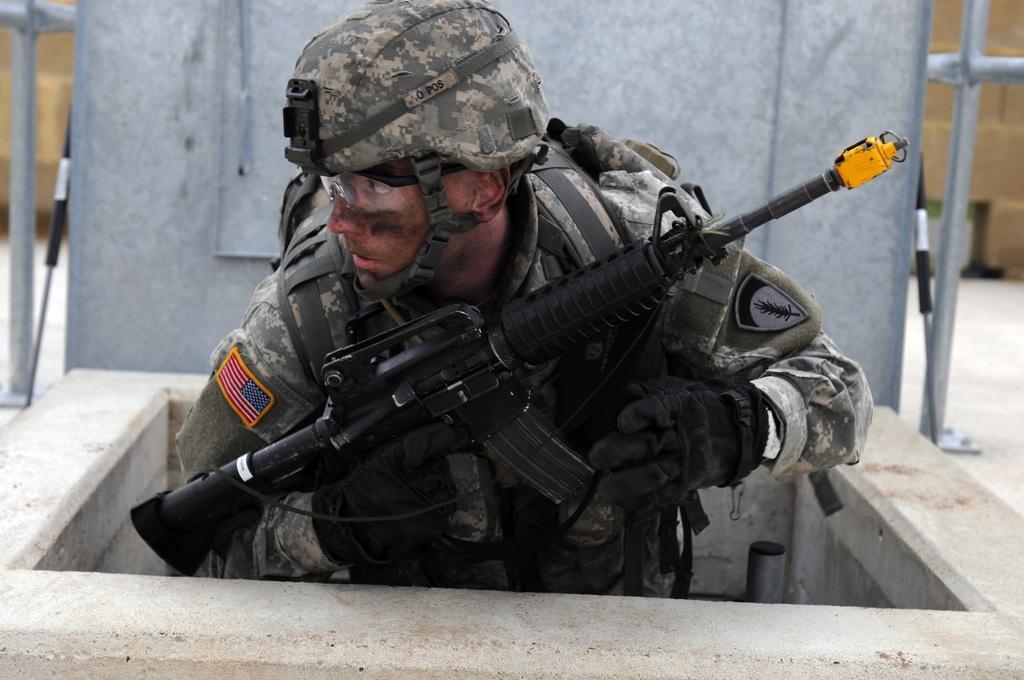How would you summarize this image in a sentence or two? In this image there a person in a uniform wearing a cap and holding a gun, there are poles and metallic object. 